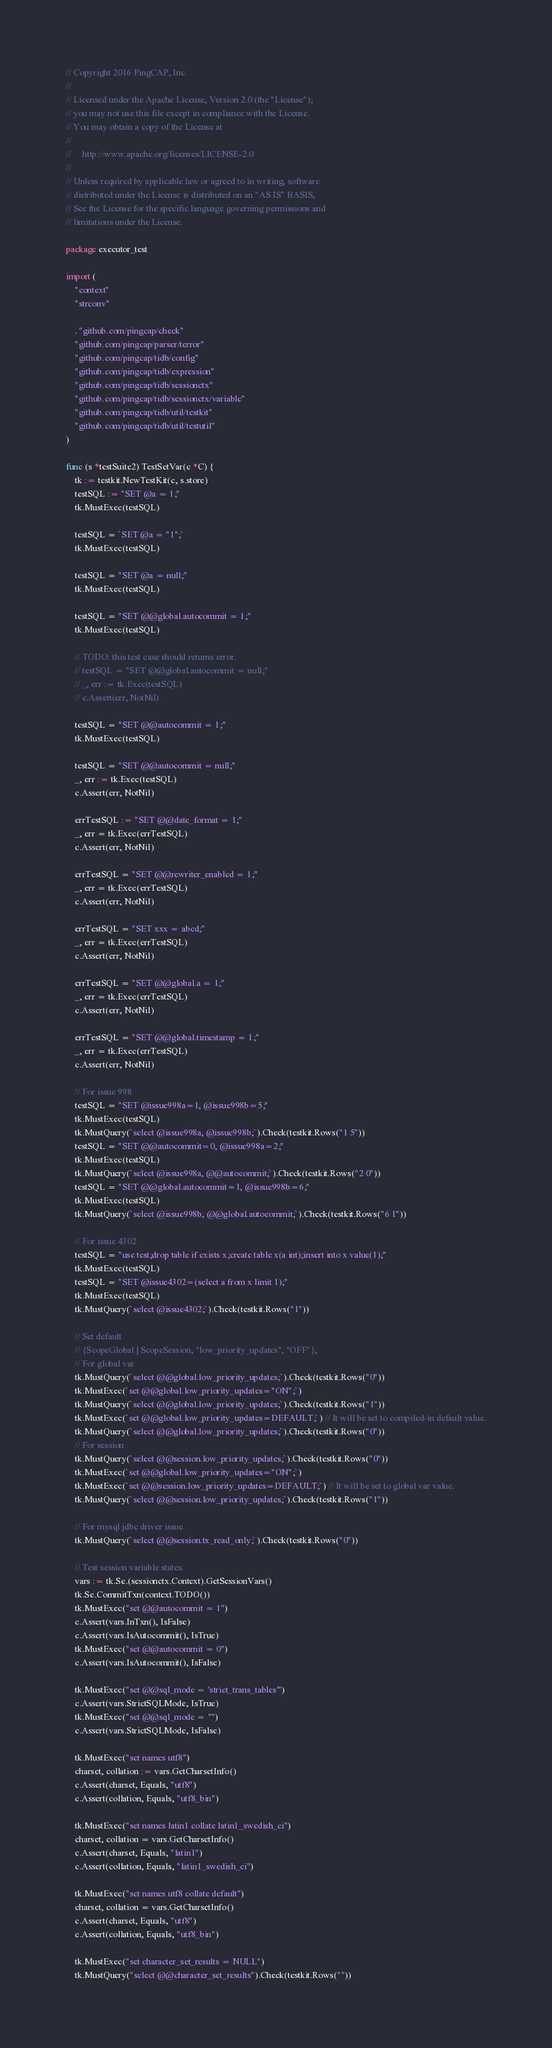Convert code to text. <code><loc_0><loc_0><loc_500><loc_500><_Go_>// Copyright 2016 PingCAP, Inc.
//
// Licensed under the Apache License, Version 2.0 (the "License");
// you may not use this file except in compliance with the License.
// You may obtain a copy of the License at
//
//     http://www.apache.org/licenses/LICENSE-2.0
//
// Unless required by applicable law or agreed to in writing, software
// distributed under the License is distributed on an "AS IS" BASIS,
// See the License for the specific language governing permissions and
// limitations under the License.

package executor_test

import (
	"context"
	"strconv"

	. "github.com/pingcap/check"
	"github.com/pingcap/parser/terror"
	"github.com/pingcap/tidb/config"
	"github.com/pingcap/tidb/expression"
	"github.com/pingcap/tidb/sessionctx"
	"github.com/pingcap/tidb/sessionctx/variable"
	"github.com/pingcap/tidb/util/testkit"
	"github.com/pingcap/tidb/util/testutil"
)

func (s *testSuite2) TestSetVar(c *C) {
	tk := testkit.NewTestKit(c, s.store)
	testSQL := "SET @a = 1;"
	tk.MustExec(testSQL)

	testSQL = `SET @a = "1";`
	tk.MustExec(testSQL)

	testSQL = "SET @a = null;"
	tk.MustExec(testSQL)

	testSQL = "SET @@global.autocommit = 1;"
	tk.MustExec(testSQL)

	// TODO: this test case should returns error.
	// testSQL = "SET @@global.autocommit = null;"
	// _, err := tk.Exec(testSQL)
	// c.Assert(err, NotNil)

	testSQL = "SET @@autocommit = 1;"
	tk.MustExec(testSQL)

	testSQL = "SET @@autocommit = null;"
	_, err := tk.Exec(testSQL)
	c.Assert(err, NotNil)

	errTestSQL := "SET @@date_format = 1;"
	_, err = tk.Exec(errTestSQL)
	c.Assert(err, NotNil)

	errTestSQL = "SET @@rewriter_enabled = 1;"
	_, err = tk.Exec(errTestSQL)
	c.Assert(err, NotNil)

	errTestSQL = "SET xxx = abcd;"
	_, err = tk.Exec(errTestSQL)
	c.Assert(err, NotNil)

	errTestSQL = "SET @@global.a = 1;"
	_, err = tk.Exec(errTestSQL)
	c.Assert(err, NotNil)

	errTestSQL = "SET @@global.timestamp = 1;"
	_, err = tk.Exec(errTestSQL)
	c.Assert(err, NotNil)

	// For issue 998
	testSQL = "SET @issue998a=1, @issue998b=5;"
	tk.MustExec(testSQL)
	tk.MustQuery(`select @issue998a, @issue998b;`).Check(testkit.Rows("1 5"))
	testSQL = "SET @@autocommit=0, @issue998a=2;"
	tk.MustExec(testSQL)
	tk.MustQuery(`select @issue998a, @@autocommit;`).Check(testkit.Rows("2 0"))
	testSQL = "SET @@global.autocommit=1, @issue998b=6;"
	tk.MustExec(testSQL)
	tk.MustQuery(`select @issue998b, @@global.autocommit;`).Check(testkit.Rows("6 1"))

	// For issue 4302
	testSQL = "use test;drop table if exists x;create table x(a int);insert into x value(1);"
	tk.MustExec(testSQL)
	testSQL = "SET @issue4302=(select a from x limit 1);"
	tk.MustExec(testSQL)
	tk.MustQuery(`select @issue4302;`).Check(testkit.Rows("1"))

	// Set default
	// {ScopeGlobal | ScopeSession, "low_priority_updates", "OFF"},
	// For global var
	tk.MustQuery(`select @@global.low_priority_updates;`).Check(testkit.Rows("0"))
	tk.MustExec(`set @@global.low_priority_updates="ON";`)
	tk.MustQuery(`select @@global.low_priority_updates;`).Check(testkit.Rows("1"))
	tk.MustExec(`set @@global.low_priority_updates=DEFAULT;`) // It will be set to compiled-in default value.
	tk.MustQuery(`select @@global.low_priority_updates;`).Check(testkit.Rows("0"))
	// For session
	tk.MustQuery(`select @@session.low_priority_updates;`).Check(testkit.Rows("0"))
	tk.MustExec(`set @@global.low_priority_updates="ON";`)
	tk.MustExec(`set @@session.low_priority_updates=DEFAULT;`) // It will be set to global var value.
	tk.MustQuery(`select @@session.low_priority_updates;`).Check(testkit.Rows("1"))

	// For mysql jdbc driver issue.
	tk.MustQuery(`select @@session.tx_read_only;`).Check(testkit.Rows("0"))

	// Test session variable states.
	vars := tk.Se.(sessionctx.Context).GetSessionVars()
	tk.Se.CommitTxn(context.TODO())
	tk.MustExec("set @@autocommit = 1")
	c.Assert(vars.InTxn(), IsFalse)
	c.Assert(vars.IsAutocommit(), IsTrue)
	tk.MustExec("set @@autocommit = 0")
	c.Assert(vars.IsAutocommit(), IsFalse)

	tk.MustExec("set @@sql_mode = 'strict_trans_tables'")
	c.Assert(vars.StrictSQLMode, IsTrue)
	tk.MustExec("set @@sql_mode = ''")
	c.Assert(vars.StrictSQLMode, IsFalse)

	tk.MustExec("set names utf8")
	charset, collation := vars.GetCharsetInfo()
	c.Assert(charset, Equals, "utf8")
	c.Assert(collation, Equals, "utf8_bin")

	tk.MustExec("set names latin1 collate latin1_swedish_ci")
	charset, collation = vars.GetCharsetInfo()
	c.Assert(charset, Equals, "latin1")
	c.Assert(collation, Equals, "latin1_swedish_ci")

	tk.MustExec("set names utf8 collate default")
	charset, collation = vars.GetCharsetInfo()
	c.Assert(charset, Equals, "utf8")
	c.Assert(collation, Equals, "utf8_bin")

	tk.MustExec("set character_set_results = NULL")
	tk.MustQuery("select @@character_set_results").Check(testkit.Rows(""))
</code> 